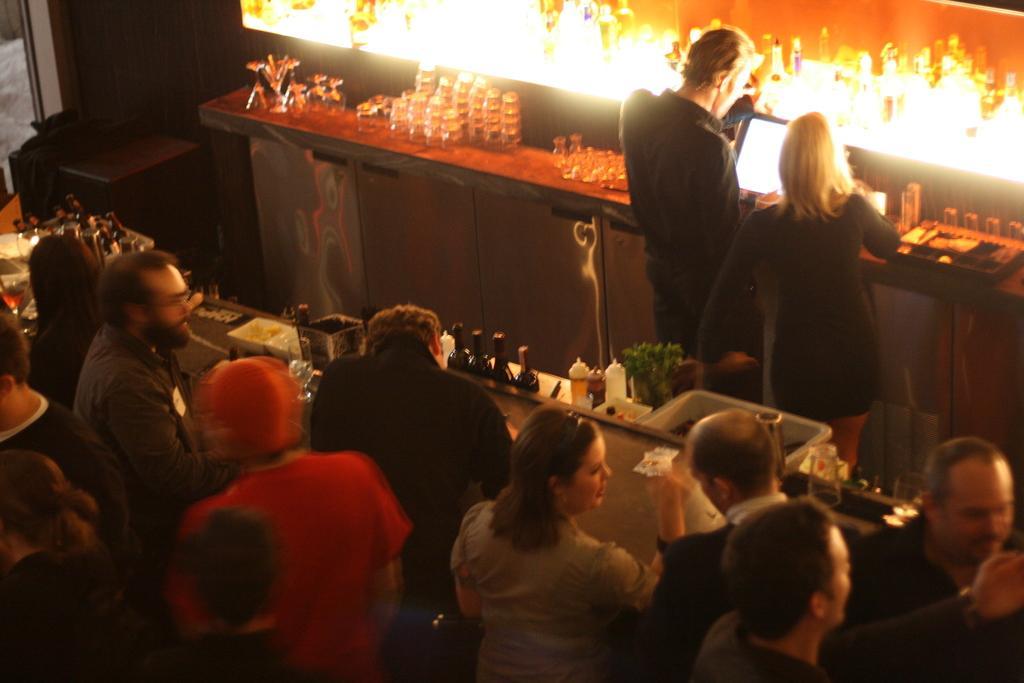Could you give a brief overview of what you see in this image? In this image in front there are few people and in front of them there is a table and on top of it there are wine bottles, glasses and few other objects. On the backside there is a table and on top of it there are glasses, laptop. In front of the table there are two people standing on the floor. In the background there is light. 